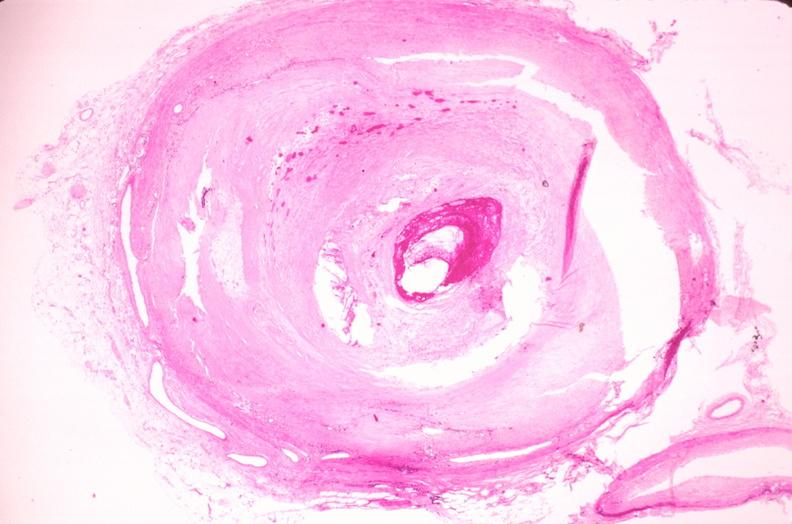does this image show coronary artery atherosclerosis?
Answer the question using a single word or phrase. Yes 